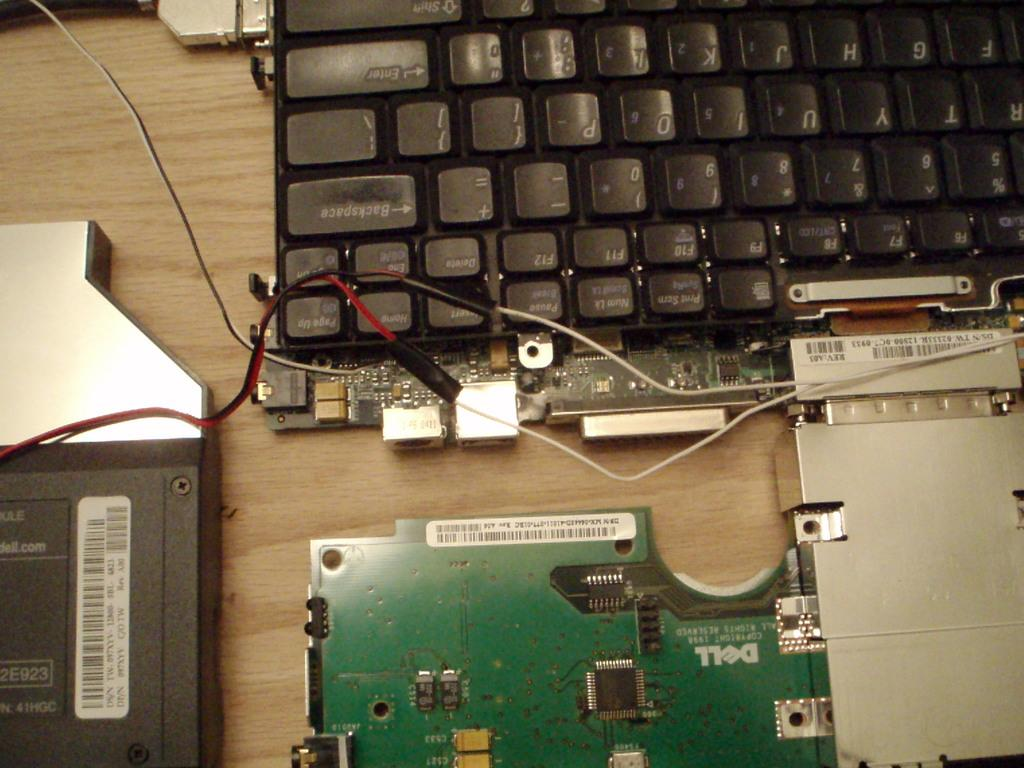Provide a one-sentence caption for the provided image. A dell computer part is beneath a keyboard. 